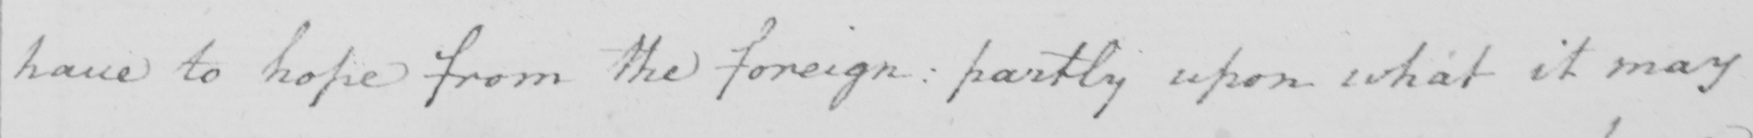Please transcribe the handwritten text in this image. have to hope from the foreign :  partly upon what it may 